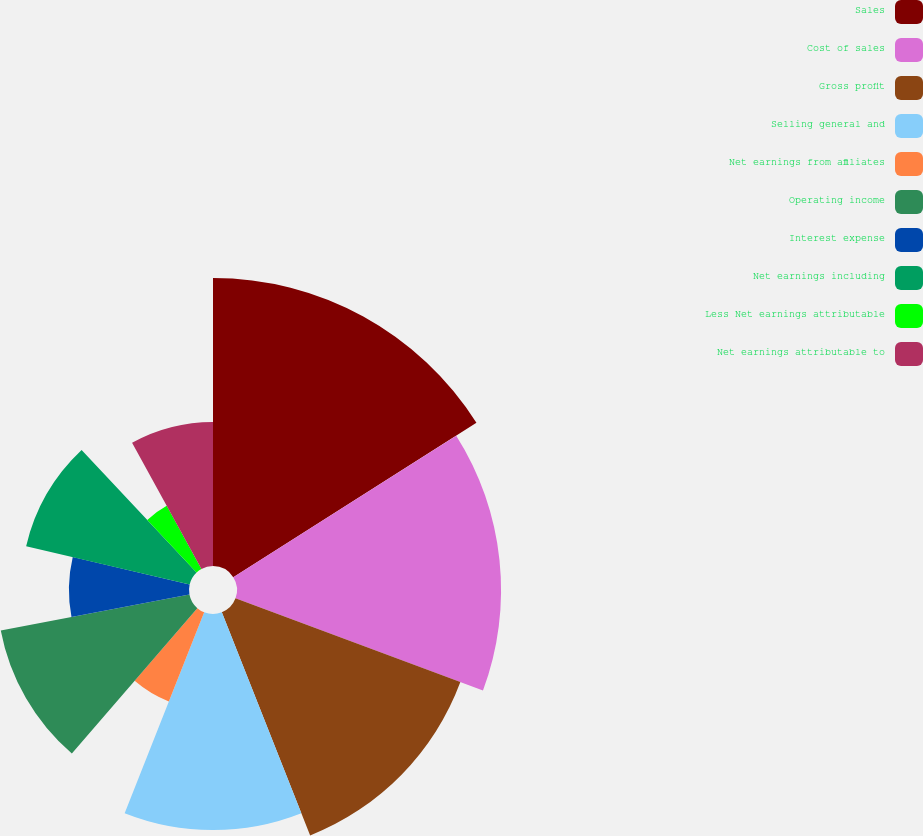<chart> <loc_0><loc_0><loc_500><loc_500><pie_chart><fcel>Sales<fcel>Cost of sales<fcel>Gross profit<fcel>Selling general and<fcel>Net earnings from affiliates<fcel>Operating income<fcel>Interest expense<fcel>Net earnings including<fcel>Less Net earnings attributable<fcel>Net earnings attributable to<nl><fcel>16.0%<fcel>14.67%<fcel>13.33%<fcel>12.0%<fcel>5.33%<fcel>10.67%<fcel>6.67%<fcel>9.33%<fcel>4.0%<fcel>8.0%<nl></chart> 